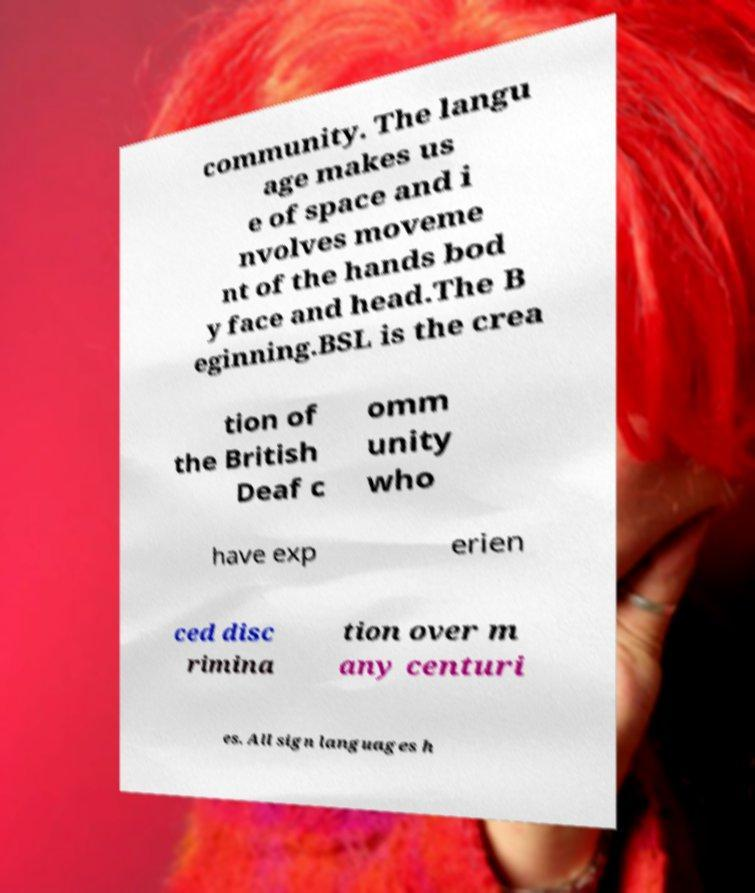What messages or text are displayed in this image? I need them in a readable, typed format. community. The langu age makes us e of space and i nvolves moveme nt of the hands bod y face and head.The B eginning.BSL is the crea tion of the British Deaf c omm unity who have exp erien ced disc rimina tion over m any centuri es. All sign languages h 